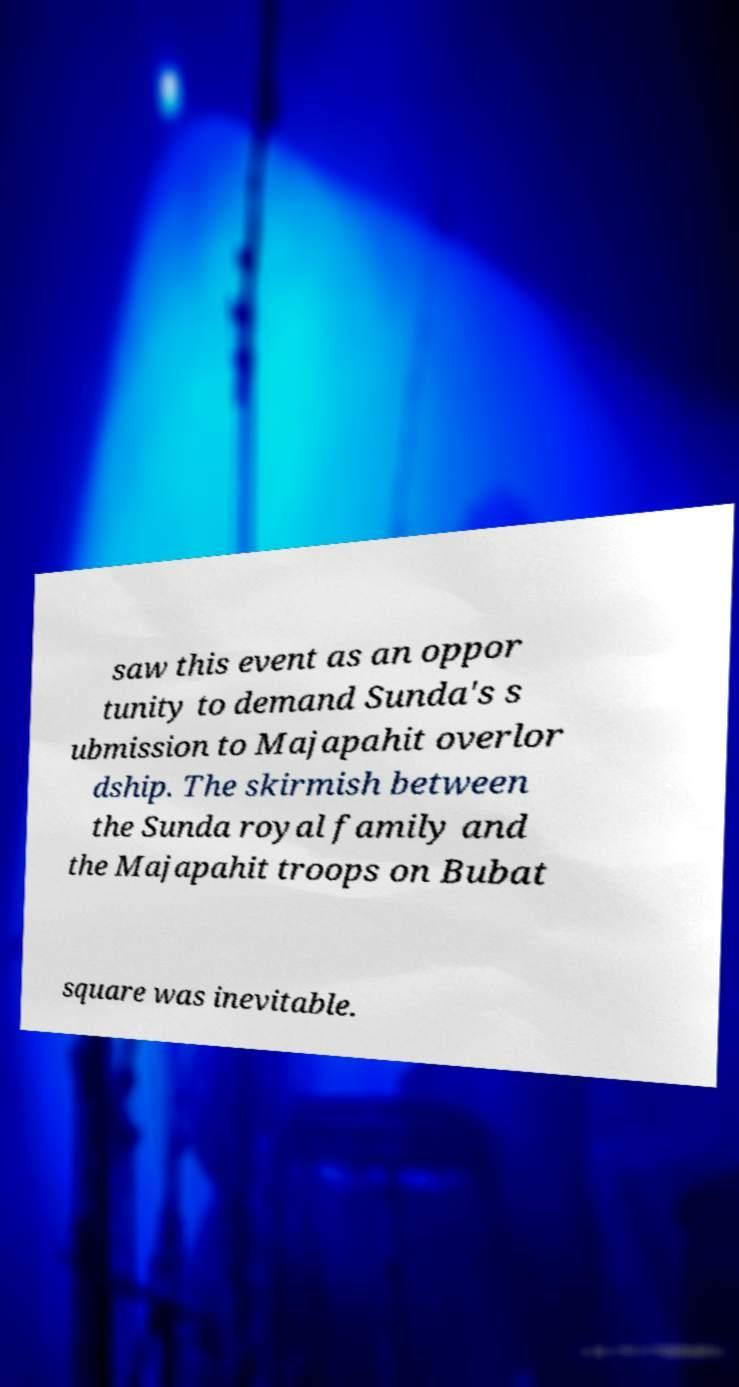Please identify and transcribe the text found in this image. saw this event as an oppor tunity to demand Sunda's s ubmission to Majapahit overlor dship. The skirmish between the Sunda royal family and the Majapahit troops on Bubat square was inevitable. 